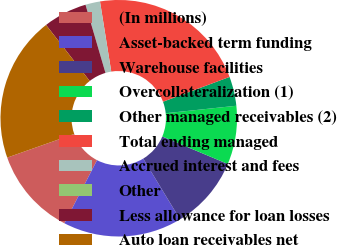<chart> <loc_0><loc_0><loc_500><loc_500><pie_chart><fcel>(In millions)<fcel>Asset-backed term funding<fcel>Warehouse facilities<fcel>Overcollateralization (1)<fcel>Other managed receivables (2)<fcel>Total ending managed<fcel>Accrued interest and fees<fcel>Other<fcel>Less allowance for loan losses<fcel>Auto loan receivables net<nl><fcel>12.0%<fcel>16.27%<fcel>10.0%<fcel>8.0%<fcel>4.0%<fcel>21.85%<fcel>2.0%<fcel>0.0%<fcel>6.0%<fcel>19.86%<nl></chart> 